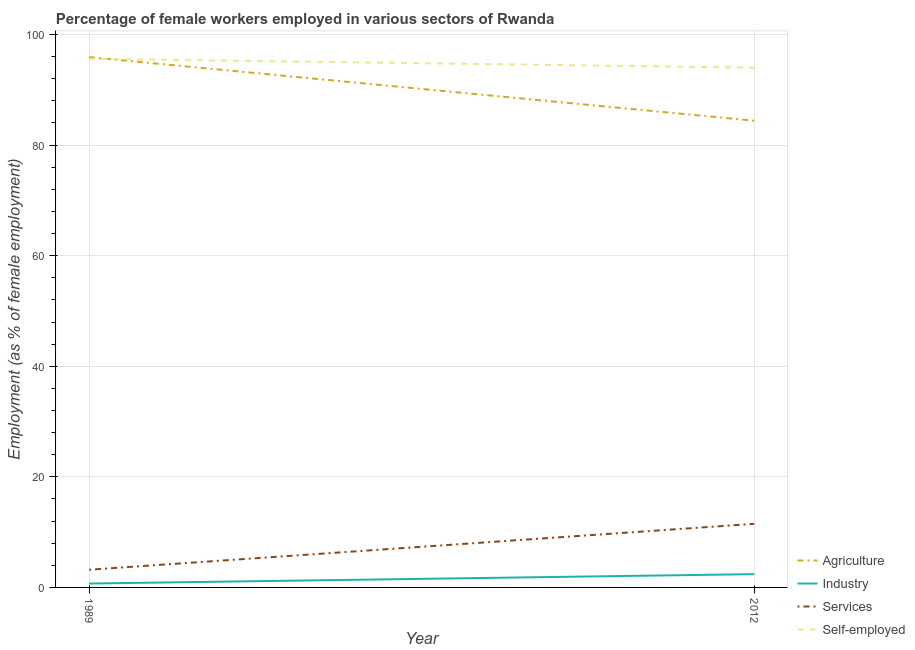How many different coloured lines are there?
Offer a very short reply. 4. Is the number of lines equal to the number of legend labels?
Keep it short and to the point. Yes. What is the percentage of female workers in industry in 2012?
Provide a short and direct response. 2.4. Across all years, what is the maximum percentage of female workers in services?
Provide a short and direct response. 11.5. Across all years, what is the minimum percentage of female workers in agriculture?
Ensure brevity in your answer.  84.4. What is the total percentage of female workers in agriculture in the graph?
Your answer should be compact. 180.3. What is the difference between the percentage of female workers in agriculture in 1989 and that in 2012?
Offer a terse response. 11.5. What is the difference between the percentage of female workers in agriculture in 1989 and the percentage of female workers in services in 2012?
Provide a succinct answer. 84.4. What is the average percentage of female workers in services per year?
Provide a short and direct response. 7.35. In the year 1989, what is the difference between the percentage of female workers in agriculture and percentage of female workers in services?
Provide a succinct answer. 92.7. In how many years, is the percentage of female workers in agriculture greater than 44 %?
Provide a short and direct response. 2. What is the ratio of the percentage of self employed female workers in 1989 to that in 2012?
Provide a succinct answer. 1.02. Is the percentage of female workers in services strictly greater than the percentage of self employed female workers over the years?
Your response must be concise. No. Is the percentage of female workers in agriculture strictly less than the percentage of female workers in services over the years?
Provide a succinct answer. No. How many years are there in the graph?
Your response must be concise. 2. What is the difference between two consecutive major ticks on the Y-axis?
Offer a terse response. 20. Does the graph contain any zero values?
Offer a terse response. No. Does the graph contain grids?
Keep it short and to the point. Yes. Where does the legend appear in the graph?
Your response must be concise. Bottom right. How many legend labels are there?
Your answer should be very brief. 4. How are the legend labels stacked?
Provide a short and direct response. Vertical. What is the title of the graph?
Keep it short and to the point. Percentage of female workers employed in various sectors of Rwanda. What is the label or title of the Y-axis?
Provide a short and direct response. Employment (as % of female employment). What is the Employment (as % of female employment) in Agriculture in 1989?
Provide a short and direct response. 95.9. What is the Employment (as % of female employment) in Industry in 1989?
Give a very brief answer. 0.7. What is the Employment (as % of female employment) in Services in 1989?
Make the answer very short. 3.2. What is the Employment (as % of female employment) in Self-employed in 1989?
Offer a terse response. 95.6. What is the Employment (as % of female employment) in Agriculture in 2012?
Provide a short and direct response. 84.4. What is the Employment (as % of female employment) in Industry in 2012?
Your response must be concise. 2.4. What is the Employment (as % of female employment) of Services in 2012?
Give a very brief answer. 11.5. What is the Employment (as % of female employment) in Self-employed in 2012?
Ensure brevity in your answer.  94. Across all years, what is the maximum Employment (as % of female employment) of Agriculture?
Your answer should be very brief. 95.9. Across all years, what is the maximum Employment (as % of female employment) in Industry?
Your response must be concise. 2.4. Across all years, what is the maximum Employment (as % of female employment) in Services?
Ensure brevity in your answer.  11.5. Across all years, what is the maximum Employment (as % of female employment) in Self-employed?
Provide a succinct answer. 95.6. Across all years, what is the minimum Employment (as % of female employment) of Agriculture?
Your response must be concise. 84.4. Across all years, what is the minimum Employment (as % of female employment) of Industry?
Give a very brief answer. 0.7. Across all years, what is the minimum Employment (as % of female employment) in Services?
Keep it short and to the point. 3.2. Across all years, what is the minimum Employment (as % of female employment) of Self-employed?
Offer a terse response. 94. What is the total Employment (as % of female employment) of Agriculture in the graph?
Your answer should be very brief. 180.3. What is the total Employment (as % of female employment) in Self-employed in the graph?
Your answer should be compact. 189.6. What is the difference between the Employment (as % of female employment) in Agriculture in 1989 and that in 2012?
Your answer should be compact. 11.5. What is the difference between the Employment (as % of female employment) of Industry in 1989 and that in 2012?
Make the answer very short. -1.7. What is the difference between the Employment (as % of female employment) of Self-employed in 1989 and that in 2012?
Offer a terse response. 1.6. What is the difference between the Employment (as % of female employment) of Agriculture in 1989 and the Employment (as % of female employment) of Industry in 2012?
Your response must be concise. 93.5. What is the difference between the Employment (as % of female employment) of Agriculture in 1989 and the Employment (as % of female employment) of Services in 2012?
Provide a short and direct response. 84.4. What is the difference between the Employment (as % of female employment) in Industry in 1989 and the Employment (as % of female employment) in Services in 2012?
Give a very brief answer. -10.8. What is the difference between the Employment (as % of female employment) in Industry in 1989 and the Employment (as % of female employment) in Self-employed in 2012?
Provide a succinct answer. -93.3. What is the difference between the Employment (as % of female employment) in Services in 1989 and the Employment (as % of female employment) in Self-employed in 2012?
Give a very brief answer. -90.8. What is the average Employment (as % of female employment) in Agriculture per year?
Ensure brevity in your answer.  90.15. What is the average Employment (as % of female employment) in Industry per year?
Provide a succinct answer. 1.55. What is the average Employment (as % of female employment) of Services per year?
Keep it short and to the point. 7.35. What is the average Employment (as % of female employment) in Self-employed per year?
Offer a terse response. 94.8. In the year 1989, what is the difference between the Employment (as % of female employment) of Agriculture and Employment (as % of female employment) of Industry?
Your answer should be very brief. 95.2. In the year 1989, what is the difference between the Employment (as % of female employment) of Agriculture and Employment (as % of female employment) of Services?
Provide a short and direct response. 92.7. In the year 1989, what is the difference between the Employment (as % of female employment) in Industry and Employment (as % of female employment) in Services?
Offer a terse response. -2.5. In the year 1989, what is the difference between the Employment (as % of female employment) in Industry and Employment (as % of female employment) in Self-employed?
Keep it short and to the point. -94.9. In the year 1989, what is the difference between the Employment (as % of female employment) of Services and Employment (as % of female employment) of Self-employed?
Your response must be concise. -92.4. In the year 2012, what is the difference between the Employment (as % of female employment) in Agriculture and Employment (as % of female employment) in Industry?
Offer a terse response. 82. In the year 2012, what is the difference between the Employment (as % of female employment) in Agriculture and Employment (as % of female employment) in Services?
Your response must be concise. 72.9. In the year 2012, what is the difference between the Employment (as % of female employment) of Industry and Employment (as % of female employment) of Services?
Keep it short and to the point. -9.1. In the year 2012, what is the difference between the Employment (as % of female employment) in Industry and Employment (as % of female employment) in Self-employed?
Provide a short and direct response. -91.6. In the year 2012, what is the difference between the Employment (as % of female employment) in Services and Employment (as % of female employment) in Self-employed?
Give a very brief answer. -82.5. What is the ratio of the Employment (as % of female employment) of Agriculture in 1989 to that in 2012?
Make the answer very short. 1.14. What is the ratio of the Employment (as % of female employment) in Industry in 1989 to that in 2012?
Provide a succinct answer. 0.29. What is the ratio of the Employment (as % of female employment) in Services in 1989 to that in 2012?
Make the answer very short. 0.28. What is the ratio of the Employment (as % of female employment) in Self-employed in 1989 to that in 2012?
Your response must be concise. 1.02. What is the difference between the highest and the second highest Employment (as % of female employment) of Industry?
Provide a succinct answer. 1.7. What is the difference between the highest and the second highest Employment (as % of female employment) in Services?
Offer a terse response. 8.3. What is the difference between the highest and the lowest Employment (as % of female employment) of Services?
Give a very brief answer. 8.3. 